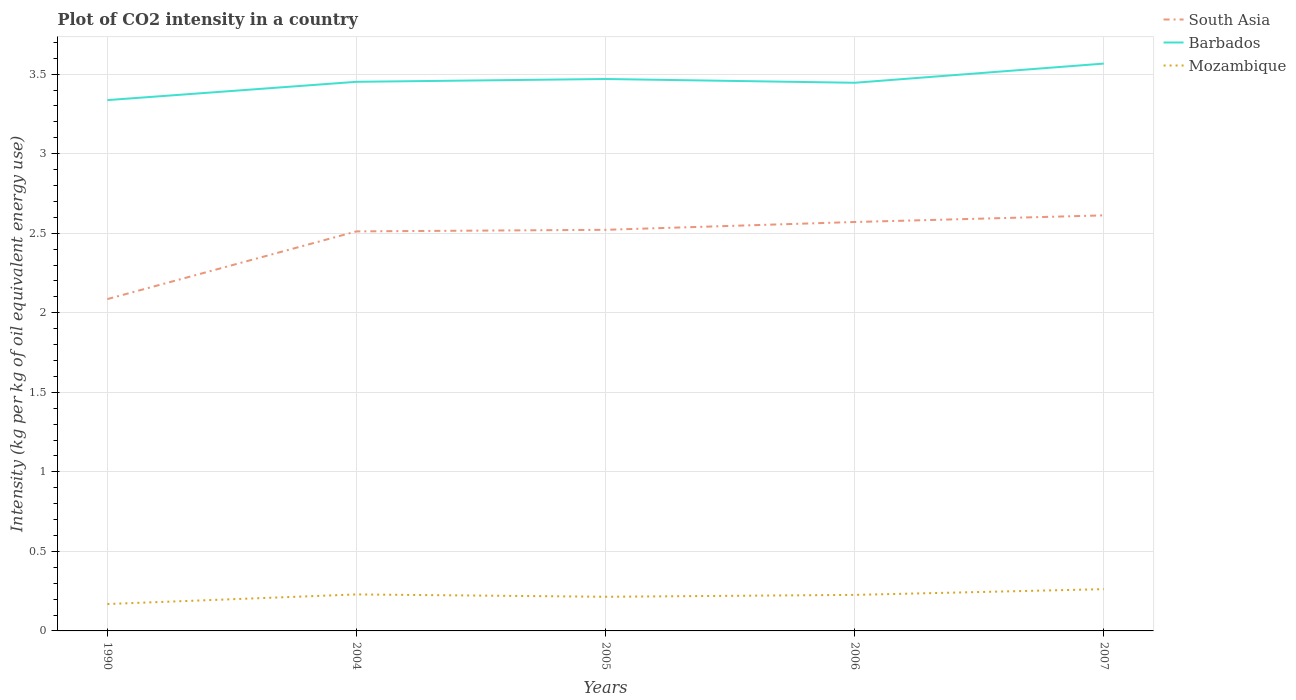Does the line corresponding to Mozambique intersect with the line corresponding to Barbados?
Give a very brief answer. No. Is the number of lines equal to the number of legend labels?
Make the answer very short. Yes. Across all years, what is the maximum CO2 intensity in in Barbados?
Ensure brevity in your answer.  3.34. What is the total CO2 intensity in in Mozambique in the graph?
Provide a short and direct response. -0.03. What is the difference between the highest and the second highest CO2 intensity in in South Asia?
Ensure brevity in your answer.  0.53. How many years are there in the graph?
Your answer should be very brief. 5. Are the values on the major ticks of Y-axis written in scientific E-notation?
Provide a succinct answer. No. How many legend labels are there?
Provide a succinct answer. 3. How are the legend labels stacked?
Your answer should be compact. Vertical. What is the title of the graph?
Ensure brevity in your answer.  Plot of CO2 intensity in a country. What is the label or title of the Y-axis?
Offer a terse response. Intensity (kg per kg of oil equivalent energy use). What is the Intensity (kg per kg of oil equivalent energy use) in South Asia in 1990?
Ensure brevity in your answer.  2.09. What is the Intensity (kg per kg of oil equivalent energy use) in Barbados in 1990?
Your response must be concise. 3.34. What is the Intensity (kg per kg of oil equivalent energy use) in Mozambique in 1990?
Give a very brief answer. 0.17. What is the Intensity (kg per kg of oil equivalent energy use) of South Asia in 2004?
Ensure brevity in your answer.  2.51. What is the Intensity (kg per kg of oil equivalent energy use) in Barbados in 2004?
Provide a succinct answer. 3.45. What is the Intensity (kg per kg of oil equivalent energy use) in Mozambique in 2004?
Make the answer very short. 0.23. What is the Intensity (kg per kg of oil equivalent energy use) in South Asia in 2005?
Ensure brevity in your answer.  2.52. What is the Intensity (kg per kg of oil equivalent energy use) in Barbados in 2005?
Provide a succinct answer. 3.47. What is the Intensity (kg per kg of oil equivalent energy use) in Mozambique in 2005?
Your answer should be compact. 0.21. What is the Intensity (kg per kg of oil equivalent energy use) of South Asia in 2006?
Your response must be concise. 2.57. What is the Intensity (kg per kg of oil equivalent energy use) in Barbados in 2006?
Your answer should be very brief. 3.45. What is the Intensity (kg per kg of oil equivalent energy use) in Mozambique in 2006?
Give a very brief answer. 0.23. What is the Intensity (kg per kg of oil equivalent energy use) in South Asia in 2007?
Make the answer very short. 2.61. What is the Intensity (kg per kg of oil equivalent energy use) of Barbados in 2007?
Provide a succinct answer. 3.57. What is the Intensity (kg per kg of oil equivalent energy use) in Mozambique in 2007?
Your response must be concise. 0.26. Across all years, what is the maximum Intensity (kg per kg of oil equivalent energy use) of South Asia?
Provide a short and direct response. 2.61. Across all years, what is the maximum Intensity (kg per kg of oil equivalent energy use) of Barbados?
Provide a short and direct response. 3.57. Across all years, what is the maximum Intensity (kg per kg of oil equivalent energy use) in Mozambique?
Make the answer very short. 0.26. Across all years, what is the minimum Intensity (kg per kg of oil equivalent energy use) in South Asia?
Your answer should be very brief. 2.09. Across all years, what is the minimum Intensity (kg per kg of oil equivalent energy use) in Barbados?
Make the answer very short. 3.34. Across all years, what is the minimum Intensity (kg per kg of oil equivalent energy use) of Mozambique?
Give a very brief answer. 0.17. What is the total Intensity (kg per kg of oil equivalent energy use) in South Asia in the graph?
Make the answer very short. 12.3. What is the total Intensity (kg per kg of oil equivalent energy use) of Barbados in the graph?
Ensure brevity in your answer.  17.27. What is the total Intensity (kg per kg of oil equivalent energy use) of Mozambique in the graph?
Make the answer very short. 1.1. What is the difference between the Intensity (kg per kg of oil equivalent energy use) in South Asia in 1990 and that in 2004?
Provide a short and direct response. -0.43. What is the difference between the Intensity (kg per kg of oil equivalent energy use) in Barbados in 1990 and that in 2004?
Give a very brief answer. -0.12. What is the difference between the Intensity (kg per kg of oil equivalent energy use) of Mozambique in 1990 and that in 2004?
Give a very brief answer. -0.06. What is the difference between the Intensity (kg per kg of oil equivalent energy use) in South Asia in 1990 and that in 2005?
Provide a succinct answer. -0.44. What is the difference between the Intensity (kg per kg of oil equivalent energy use) in Barbados in 1990 and that in 2005?
Provide a short and direct response. -0.13. What is the difference between the Intensity (kg per kg of oil equivalent energy use) of Mozambique in 1990 and that in 2005?
Provide a succinct answer. -0.05. What is the difference between the Intensity (kg per kg of oil equivalent energy use) of South Asia in 1990 and that in 2006?
Your answer should be compact. -0.48. What is the difference between the Intensity (kg per kg of oil equivalent energy use) of Barbados in 1990 and that in 2006?
Your response must be concise. -0.11. What is the difference between the Intensity (kg per kg of oil equivalent energy use) in Mozambique in 1990 and that in 2006?
Ensure brevity in your answer.  -0.06. What is the difference between the Intensity (kg per kg of oil equivalent energy use) of South Asia in 1990 and that in 2007?
Provide a succinct answer. -0.53. What is the difference between the Intensity (kg per kg of oil equivalent energy use) of Barbados in 1990 and that in 2007?
Give a very brief answer. -0.23. What is the difference between the Intensity (kg per kg of oil equivalent energy use) of Mozambique in 1990 and that in 2007?
Keep it short and to the point. -0.09. What is the difference between the Intensity (kg per kg of oil equivalent energy use) in South Asia in 2004 and that in 2005?
Offer a very short reply. -0.01. What is the difference between the Intensity (kg per kg of oil equivalent energy use) in Barbados in 2004 and that in 2005?
Your answer should be very brief. -0.02. What is the difference between the Intensity (kg per kg of oil equivalent energy use) of Mozambique in 2004 and that in 2005?
Your response must be concise. 0.01. What is the difference between the Intensity (kg per kg of oil equivalent energy use) of South Asia in 2004 and that in 2006?
Make the answer very short. -0.06. What is the difference between the Intensity (kg per kg of oil equivalent energy use) of Barbados in 2004 and that in 2006?
Your response must be concise. 0.01. What is the difference between the Intensity (kg per kg of oil equivalent energy use) of Mozambique in 2004 and that in 2006?
Ensure brevity in your answer.  0. What is the difference between the Intensity (kg per kg of oil equivalent energy use) in South Asia in 2004 and that in 2007?
Offer a terse response. -0.1. What is the difference between the Intensity (kg per kg of oil equivalent energy use) in Barbados in 2004 and that in 2007?
Make the answer very short. -0.11. What is the difference between the Intensity (kg per kg of oil equivalent energy use) of Mozambique in 2004 and that in 2007?
Offer a terse response. -0.03. What is the difference between the Intensity (kg per kg of oil equivalent energy use) in South Asia in 2005 and that in 2006?
Give a very brief answer. -0.05. What is the difference between the Intensity (kg per kg of oil equivalent energy use) of Barbados in 2005 and that in 2006?
Give a very brief answer. 0.02. What is the difference between the Intensity (kg per kg of oil equivalent energy use) of Mozambique in 2005 and that in 2006?
Give a very brief answer. -0.01. What is the difference between the Intensity (kg per kg of oil equivalent energy use) of South Asia in 2005 and that in 2007?
Offer a terse response. -0.09. What is the difference between the Intensity (kg per kg of oil equivalent energy use) of Barbados in 2005 and that in 2007?
Offer a terse response. -0.1. What is the difference between the Intensity (kg per kg of oil equivalent energy use) of Mozambique in 2005 and that in 2007?
Give a very brief answer. -0.05. What is the difference between the Intensity (kg per kg of oil equivalent energy use) in South Asia in 2006 and that in 2007?
Ensure brevity in your answer.  -0.04. What is the difference between the Intensity (kg per kg of oil equivalent energy use) in Barbados in 2006 and that in 2007?
Provide a short and direct response. -0.12. What is the difference between the Intensity (kg per kg of oil equivalent energy use) in Mozambique in 2006 and that in 2007?
Keep it short and to the point. -0.04. What is the difference between the Intensity (kg per kg of oil equivalent energy use) in South Asia in 1990 and the Intensity (kg per kg of oil equivalent energy use) in Barbados in 2004?
Ensure brevity in your answer.  -1.37. What is the difference between the Intensity (kg per kg of oil equivalent energy use) of South Asia in 1990 and the Intensity (kg per kg of oil equivalent energy use) of Mozambique in 2004?
Keep it short and to the point. 1.86. What is the difference between the Intensity (kg per kg of oil equivalent energy use) in Barbados in 1990 and the Intensity (kg per kg of oil equivalent energy use) in Mozambique in 2004?
Provide a short and direct response. 3.11. What is the difference between the Intensity (kg per kg of oil equivalent energy use) in South Asia in 1990 and the Intensity (kg per kg of oil equivalent energy use) in Barbados in 2005?
Give a very brief answer. -1.38. What is the difference between the Intensity (kg per kg of oil equivalent energy use) in South Asia in 1990 and the Intensity (kg per kg of oil equivalent energy use) in Mozambique in 2005?
Make the answer very short. 1.87. What is the difference between the Intensity (kg per kg of oil equivalent energy use) in Barbados in 1990 and the Intensity (kg per kg of oil equivalent energy use) in Mozambique in 2005?
Ensure brevity in your answer.  3.12. What is the difference between the Intensity (kg per kg of oil equivalent energy use) of South Asia in 1990 and the Intensity (kg per kg of oil equivalent energy use) of Barbados in 2006?
Ensure brevity in your answer.  -1.36. What is the difference between the Intensity (kg per kg of oil equivalent energy use) of South Asia in 1990 and the Intensity (kg per kg of oil equivalent energy use) of Mozambique in 2006?
Your answer should be compact. 1.86. What is the difference between the Intensity (kg per kg of oil equivalent energy use) of Barbados in 1990 and the Intensity (kg per kg of oil equivalent energy use) of Mozambique in 2006?
Make the answer very short. 3.11. What is the difference between the Intensity (kg per kg of oil equivalent energy use) in South Asia in 1990 and the Intensity (kg per kg of oil equivalent energy use) in Barbados in 2007?
Offer a very short reply. -1.48. What is the difference between the Intensity (kg per kg of oil equivalent energy use) of South Asia in 1990 and the Intensity (kg per kg of oil equivalent energy use) of Mozambique in 2007?
Keep it short and to the point. 1.82. What is the difference between the Intensity (kg per kg of oil equivalent energy use) of Barbados in 1990 and the Intensity (kg per kg of oil equivalent energy use) of Mozambique in 2007?
Your answer should be very brief. 3.07. What is the difference between the Intensity (kg per kg of oil equivalent energy use) of South Asia in 2004 and the Intensity (kg per kg of oil equivalent energy use) of Barbados in 2005?
Provide a short and direct response. -0.96. What is the difference between the Intensity (kg per kg of oil equivalent energy use) in South Asia in 2004 and the Intensity (kg per kg of oil equivalent energy use) in Mozambique in 2005?
Provide a succinct answer. 2.3. What is the difference between the Intensity (kg per kg of oil equivalent energy use) of Barbados in 2004 and the Intensity (kg per kg of oil equivalent energy use) of Mozambique in 2005?
Provide a succinct answer. 3.24. What is the difference between the Intensity (kg per kg of oil equivalent energy use) in South Asia in 2004 and the Intensity (kg per kg of oil equivalent energy use) in Barbados in 2006?
Offer a terse response. -0.93. What is the difference between the Intensity (kg per kg of oil equivalent energy use) in South Asia in 2004 and the Intensity (kg per kg of oil equivalent energy use) in Mozambique in 2006?
Make the answer very short. 2.29. What is the difference between the Intensity (kg per kg of oil equivalent energy use) of Barbados in 2004 and the Intensity (kg per kg of oil equivalent energy use) of Mozambique in 2006?
Provide a short and direct response. 3.23. What is the difference between the Intensity (kg per kg of oil equivalent energy use) of South Asia in 2004 and the Intensity (kg per kg of oil equivalent energy use) of Barbados in 2007?
Your response must be concise. -1.05. What is the difference between the Intensity (kg per kg of oil equivalent energy use) of South Asia in 2004 and the Intensity (kg per kg of oil equivalent energy use) of Mozambique in 2007?
Your answer should be compact. 2.25. What is the difference between the Intensity (kg per kg of oil equivalent energy use) of Barbados in 2004 and the Intensity (kg per kg of oil equivalent energy use) of Mozambique in 2007?
Your response must be concise. 3.19. What is the difference between the Intensity (kg per kg of oil equivalent energy use) of South Asia in 2005 and the Intensity (kg per kg of oil equivalent energy use) of Barbados in 2006?
Your answer should be compact. -0.92. What is the difference between the Intensity (kg per kg of oil equivalent energy use) of South Asia in 2005 and the Intensity (kg per kg of oil equivalent energy use) of Mozambique in 2006?
Make the answer very short. 2.29. What is the difference between the Intensity (kg per kg of oil equivalent energy use) of Barbados in 2005 and the Intensity (kg per kg of oil equivalent energy use) of Mozambique in 2006?
Ensure brevity in your answer.  3.24. What is the difference between the Intensity (kg per kg of oil equivalent energy use) in South Asia in 2005 and the Intensity (kg per kg of oil equivalent energy use) in Barbados in 2007?
Provide a short and direct response. -1.04. What is the difference between the Intensity (kg per kg of oil equivalent energy use) in South Asia in 2005 and the Intensity (kg per kg of oil equivalent energy use) in Mozambique in 2007?
Provide a succinct answer. 2.26. What is the difference between the Intensity (kg per kg of oil equivalent energy use) in Barbados in 2005 and the Intensity (kg per kg of oil equivalent energy use) in Mozambique in 2007?
Provide a succinct answer. 3.21. What is the difference between the Intensity (kg per kg of oil equivalent energy use) in South Asia in 2006 and the Intensity (kg per kg of oil equivalent energy use) in Barbados in 2007?
Provide a succinct answer. -1. What is the difference between the Intensity (kg per kg of oil equivalent energy use) of South Asia in 2006 and the Intensity (kg per kg of oil equivalent energy use) of Mozambique in 2007?
Provide a succinct answer. 2.31. What is the difference between the Intensity (kg per kg of oil equivalent energy use) in Barbados in 2006 and the Intensity (kg per kg of oil equivalent energy use) in Mozambique in 2007?
Your answer should be very brief. 3.18. What is the average Intensity (kg per kg of oil equivalent energy use) of South Asia per year?
Make the answer very short. 2.46. What is the average Intensity (kg per kg of oil equivalent energy use) of Barbados per year?
Provide a succinct answer. 3.45. What is the average Intensity (kg per kg of oil equivalent energy use) of Mozambique per year?
Your answer should be very brief. 0.22. In the year 1990, what is the difference between the Intensity (kg per kg of oil equivalent energy use) of South Asia and Intensity (kg per kg of oil equivalent energy use) of Barbados?
Your response must be concise. -1.25. In the year 1990, what is the difference between the Intensity (kg per kg of oil equivalent energy use) of South Asia and Intensity (kg per kg of oil equivalent energy use) of Mozambique?
Provide a short and direct response. 1.92. In the year 1990, what is the difference between the Intensity (kg per kg of oil equivalent energy use) of Barbados and Intensity (kg per kg of oil equivalent energy use) of Mozambique?
Make the answer very short. 3.17. In the year 2004, what is the difference between the Intensity (kg per kg of oil equivalent energy use) in South Asia and Intensity (kg per kg of oil equivalent energy use) in Barbados?
Provide a succinct answer. -0.94. In the year 2004, what is the difference between the Intensity (kg per kg of oil equivalent energy use) in South Asia and Intensity (kg per kg of oil equivalent energy use) in Mozambique?
Ensure brevity in your answer.  2.28. In the year 2004, what is the difference between the Intensity (kg per kg of oil equivalent energy use) of Barbados and Intensity (kg per kg of oil equivalent energy use) of Mozambique?
Offer a very short reply. 3.22. In the year 2005, what is the difference between the Intensity (kg per kg of oil equivalent energy use) of South Asia and Intensity (kg per kg of oil equivalent energy use) of Barbados?
Provide a succinct answer. -0.95. In the year 2005, what is the difference between the Intensity (kg per kg of oil equivalent energy use) in South Asia and Intensity (kg per kg of oil equivalent energy use) in Mozambique?
Ensure brevity in your answer.  2.31. In the year 2005, what is the difference between the Intensity (kg per kg of oil equivalent energy use) of Barbados and Intensity (kg per kg of oil equivalent energy use) of Mozambique?
Make the answer very short. 3.25. In the year 2006, what is the difference between the Intensity (kg per kg of oil equivalent energy use) in South Asia and Intensity (kg per kg of oil equivalent energy use) in Barbados?
Keep it short and to the point. -0.88. In the year 2006, what is the difference between the Intensity (kg per kg of oil equivalent energy use) in South Asia and Intensity (kg per kg of oil equivalent energy use) in Mozambique?
Ensure brevity in your answer.  2.34. In the year 2006, what is the difference between the Intensity (kg per kg of oil equivalent energy use) in Barbados and Intensity (kg per kg of oil equivalent energy use) in Mozambique?
Your response must be concise. 3.22. In the year 2007, what is the difference between the Intensity (kg per kg of oil equivalent energy use) in South Asia and Intensity (kg per kg of oil equivalent energy use) in Barbados?
Your answer should be compact. -0.95. In the year 2007, what is the difference between the Intensity (kg per kg of oil equivalent energy use) of South Asia and Intensity (kg per kg of oil equivalent energy use) of Mozambique?
Provide a succinct answer. 2.35. In the year 2007, what is the difference between the Intensity (kg per kg of oil equivalent energy use) of Barbados and Intensity (kg per kg of oil equivalent energy use) of Mozambique?
Offer a terse response. 3.3. What is the ratio of the Intensity (kg per kg of oil equivalent energy use) in South Asia in 1990 to that in 2004?
Your response must be concise. 0.83. What is the ratio of the Intensity (kg per kg of oil equivalent energy use) of Barbados in 1990 to that in 2004?
Your answer should be compact. 0.97. What is the ratio of the Intensity (kg per kg of oil equivalent energy use) of Mozambique in 1990 to that in 2004?
Offer a very short reply. 0.74. What is the ratio of the Intensity (kg per kg of oil equivalent energy use) of South Asia in 1990 to that in 2005?
Provide a succinct answer. 0.83. What is the ratio of the Intensity (kg per kg of oil equivalent energy use) in Barbados in 1990 to that in 2005?
Keep it short and to the point. 0.96. What is the ratio of the Intensity (kg per kg of oil equivalent energy use) of Mozambique in 1990 to that in 2005?
Offer a terse response. 0.79. What is the ratio of the Intensity (kg per kg of oil equivalent energy use) in South Asia in 1990 to that in 2006?
Offer a terse response. 0.81. What is the ratio of the Intensity (kg per kg of oil equivalent energy use) in Barbados in 1990 to that in 2006?
Give a very brief answer. 0.97. What is the ratio of the Intensity (kg per kg of oil equivalent energy use) of Mozambique in 1990 to that in 2006?
Your answer should be compact. 0.75. What is the ratio of the Intensity (kg per kg of oil equivalent energy use) in South Asia in 1990 to that in 2007?
Provide a short and direct response. 0.8. What is the ratio of the Intensity (kg per kg of oil equivalent energy use) in Barbados in 1990 to that in 2007?
Provide a succinct answer. 0.94. What is the ratio of the Intensity (kg per kg of oil equivalent energy use) of Mozambique in 1990 to that in 2007?
Your answer should be very brief. 0.64. What is the ratio of the Intensity (kg per kg of oil equivalent energy use) in South Asia in 2004 to that in 2005?
Offer a very short reply. 1. What is the ratio of the Intensity (kg per kg of oil equivalent energy use) in Mozambique in 2004 to that in 2005?
Provide a succinct answer. 1.07. What is the ratio of the Intensity (kg per kg of oil equivalent energy use) of South Asia in 2004 to that in 2006?
Keep it short and to the point. 0.98. What is the ratio of the Intensity (kg per kg of oil equivalent energy use) of Barbados in 2004 to that in 2006?
Keep it short and to the point. 1. What is the ratio of the Intensity (kg per kg of oil equivalent energy use) of South Asia in 2004 to that in 2007?
Ensure brevity in your answer.  0.96. What is the ratio of the Intensity (kg per kg of oil equivalent energy use) of Barbados in 2004 to that in 2007?
Your answer should be very brief. 0.97. What is the ratio of the Intensity (kg per kg of oil equivalent energy use) in Mozambique in 2004 to that in 2007?
Offer a very short reply. 0.87. What is the ratio of the Intensity (kg per kg of oil equivalent energy use) of South Asia in 2005 to that in 2006?
Provide a short and direct response. 0.98. What is the ratio of the Intensity (kg per kg of oil equivalent energy use) of Barbados in 2005 to that in 2006?
Provide a short and direct response. 1.01. What is the ratio of the Intensity (kg per kg of oil equivalent energy use) in Mozambique in 2005 to that in 2006?
Keep it short and to the point. 0.95. What is the ratio of the Intensity (kg per kg of oil equivalent energy use) in South Asia in 2005 to that in 2007?
Give a very brief answer. 0.97. What is the ratio of the Intensity (kg per kg of oil equivalent energy use) in Barbados in 2005 to that in 2007?
Provide a short and direct response. 0.97. What is the ratio of the Intensity (kg per kg of oil equivalent energy use) of Mozambique in 2005 to that in 2007?
Offer a very short reply. 0.82. What is the ratio of the Intensity (kg per kg of oil equivalent energy use) in South Asia in 2006 to that in 2007?
Offer a terse response. 0.98. What is the ratio of the Intensity (kg per kg of oil equivalent energy use) of Barbados in 2006 to that in 2007?
Keep it short and to the point. 0.97. What is the ratio of the Intensity (kg per kg of oil equivalent energy use) of Mozambique in 2006 to that in 2007?
Keep it short and to the point. 0.86. What is the difference between the highest and the second highest Intensity (kg per kg of oil equivalent energy use) in South Asia?
Ensure brevity in your answer.  0.04. What is the difference between the highest and the second highest Intensity (kg per kg of oil equivalent energy use) in Barbados?
Ensure brevity in your answer.  0.1. What is the difference between the highest and the second highest Intensity (kg per kg of oil equivalent energy use) in Mozambique?
Your answer should be very brief. 0.03. What is the difference between the highest and the lowest Intensity (kg per kg of oil equivalent energy use) in South Asia?
Your answer should be compact. 0.53. What is the difference between the highest and the lowest Intensity (kg per kg of oil equivalent energy use) of Barbados?
Provide a short and direct response. 0.23. What is the difference between the highest and the lowest Intensity (kg per kg of oil equivalent energy use) of Mozambique?
Ensure brevity in your answer.  0.09. 